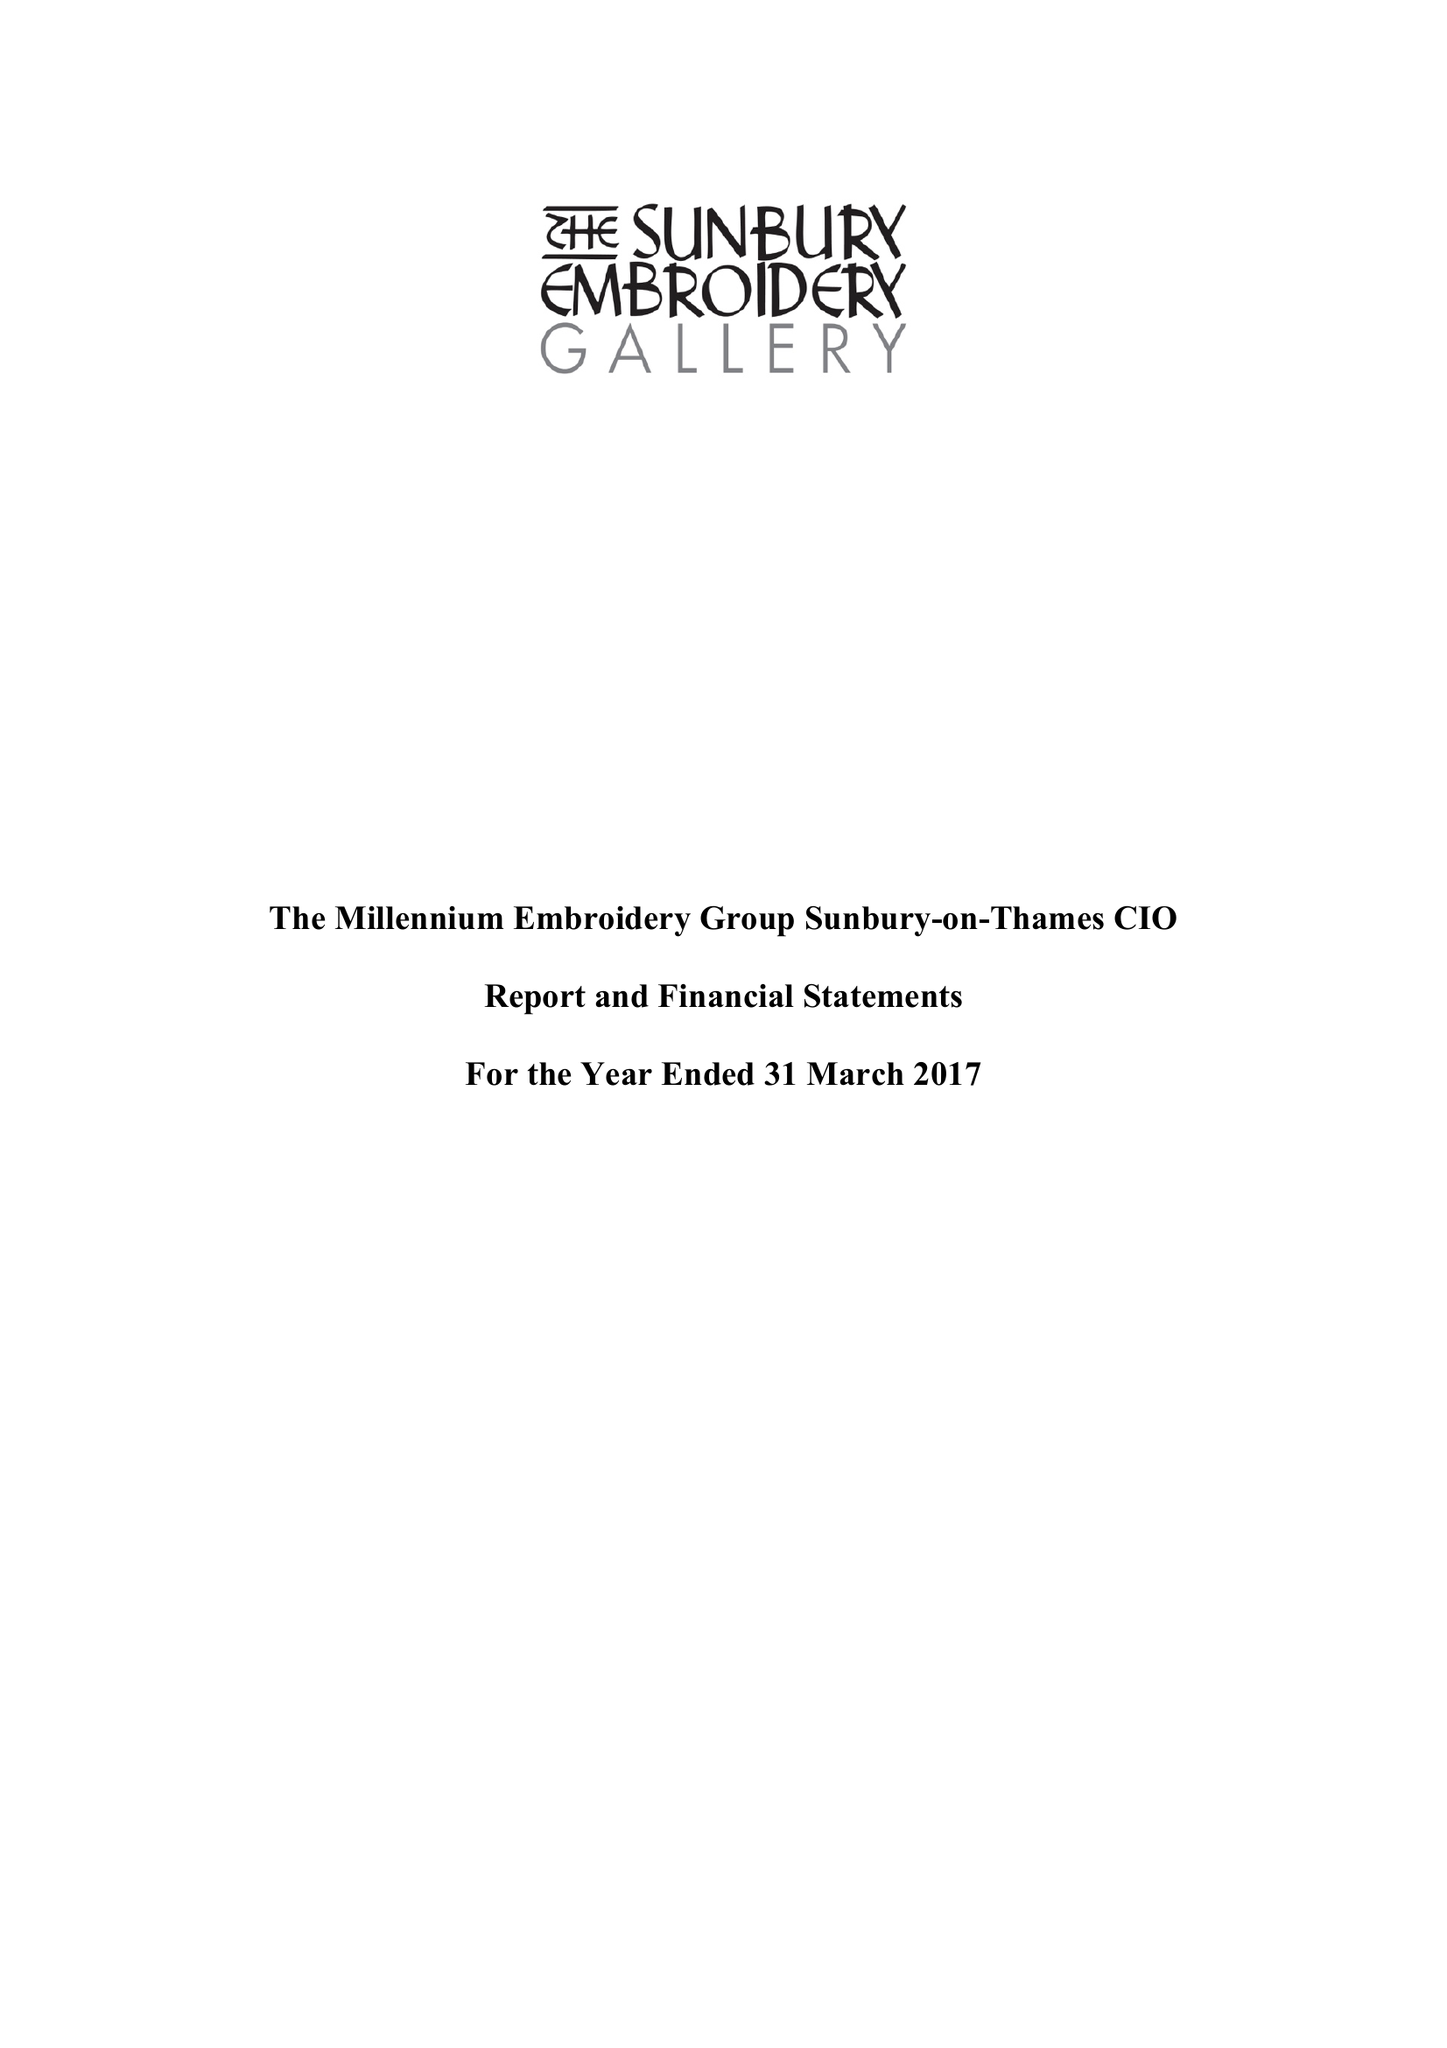What is the value for the report_date?
Answer the question using a single word or phrase. 2017-03-31 